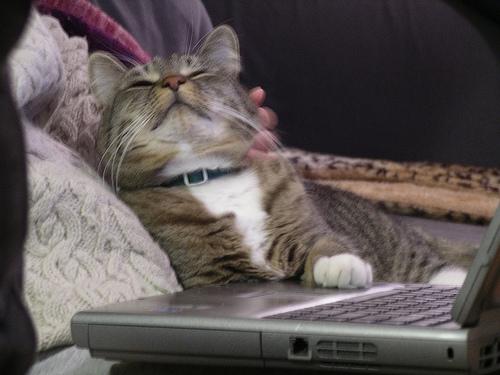Where is the cat's face?
Quick response, please. Looking up. What color is the cat's paws?
Keep it brief. White. Does the cat have a collar?
Keep it brief. Yes. What does the cat have around its neck?
Quick response, please. Collar. What is the cat leaning on?
Be succinct. Person. What is the cat lying on?
Give a very brief answer. Laptop. 